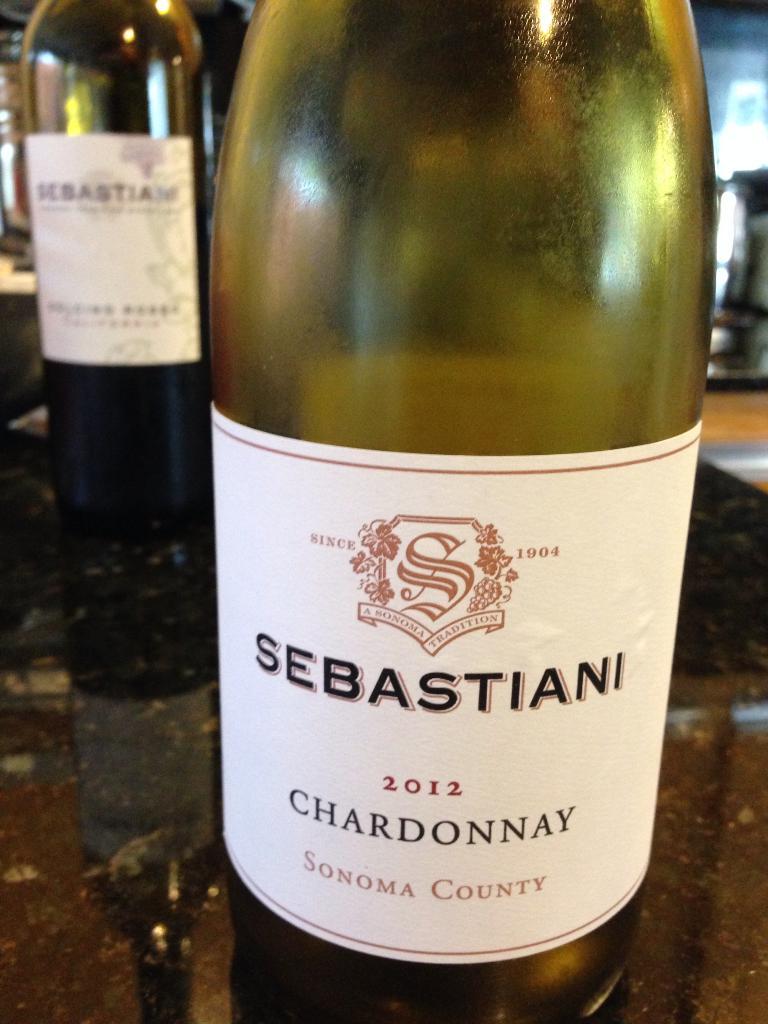Is this white or red wine?
Give a very brief answer. Answering does not require reading text in the image. When was this wine made?
Provide a short and direct response. 2012. 